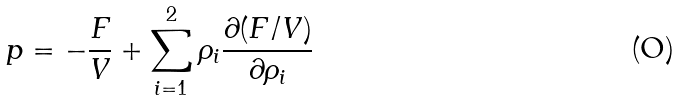Convert formula to latex. <formula><loc_0><loc_0><loc_500><loc_500>p = - \frac { F } { V } + \sum _ { i = 1 } ^ { 2 } \rho _ { i } \frac { \partial ( F / V ) } { \partial \rho _ { i } }</formula> 